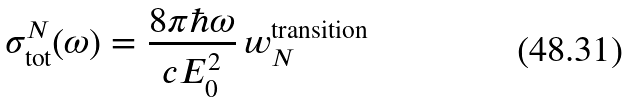Convert formula to latex. <formula><loc_0><loc_0><loc_500><loc_500>\sigma ^ { N } _ { \text {tot} } ( \omega ) = \frac { 8 \pi \hbar { \omega } } { c E _ { 0 } ^ { 2 } } \, { w ^ { \text {transition} } _ { N } }</formula> 